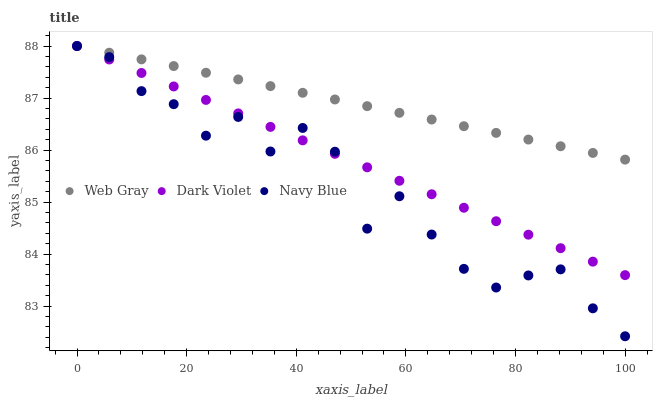Does Navy Blue have the minimum area under the curve?
Answer yes or no. Yes. Does Web Gray have the maximum area under the curve?
Answer yes or no. Yes. Does Dark Violet have the minimum area under the curve?
Answer yes or no. No. Does Dark Violet have the maximum area under the curve?
Answer yes or no. No. Is Web Gray the smoothest?
Answer yes or no. Yes. Is Navy Blue the roughest?
Answer yes or no. Yes. Is Dark Violet the smoothest?
Answer yes or no. No. Is Dark Violet the roughest?
Answer yes or no. No. Does Navy Blue have the lowest value?
Answer yes or no. Yes. Does Dark Violet have the lowest value?
Answer yes or no. No. Does Dark Violet have the highest value?
Answer yes or no. Yes. Does Navy Blue intersect Dark Violet?
Answer yes or no. Yes. Is Navy Blue less than Dark Violet?
Answer yes or no. No. Is Navy Blue greater than Dark Violet?
Answer yes or no. No. 